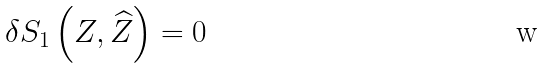Convert formula to latex. <formula><loc_0><loc_0><loc_500><loc_500>\delta S _ { 1 } \left ( Z , \widehat { Z } \right ) = 0</formula> 